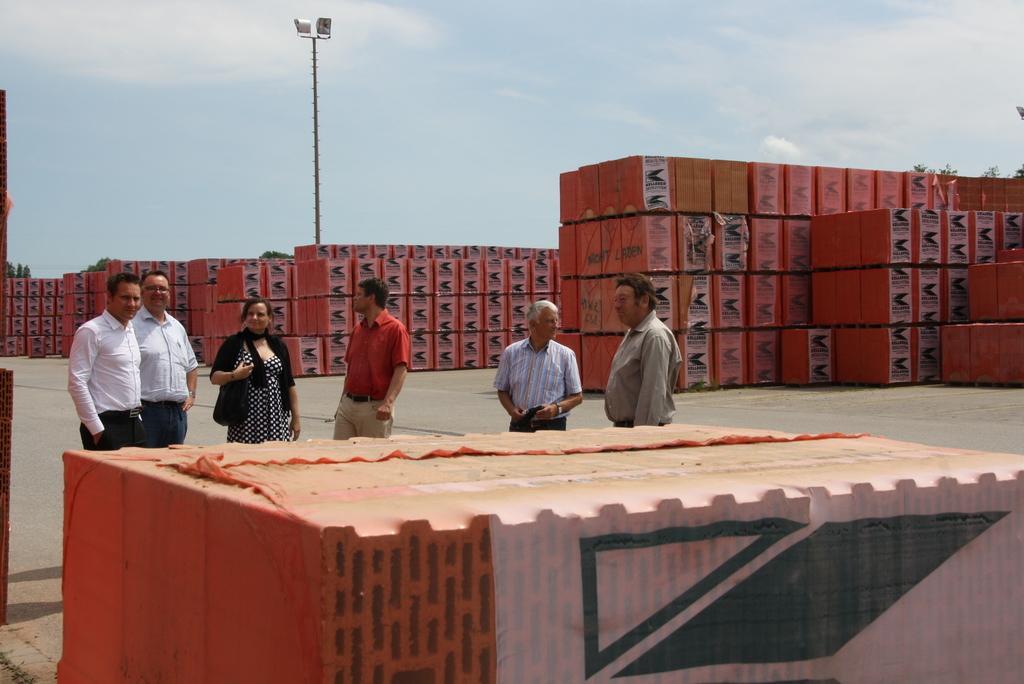Could you give a brief overview of what you see in this image? In the left side 2 men are standing both of them wore white color shirts beside them there is a woman, who is standing she wore a black color dress. At the top it's a cloudy sky. 